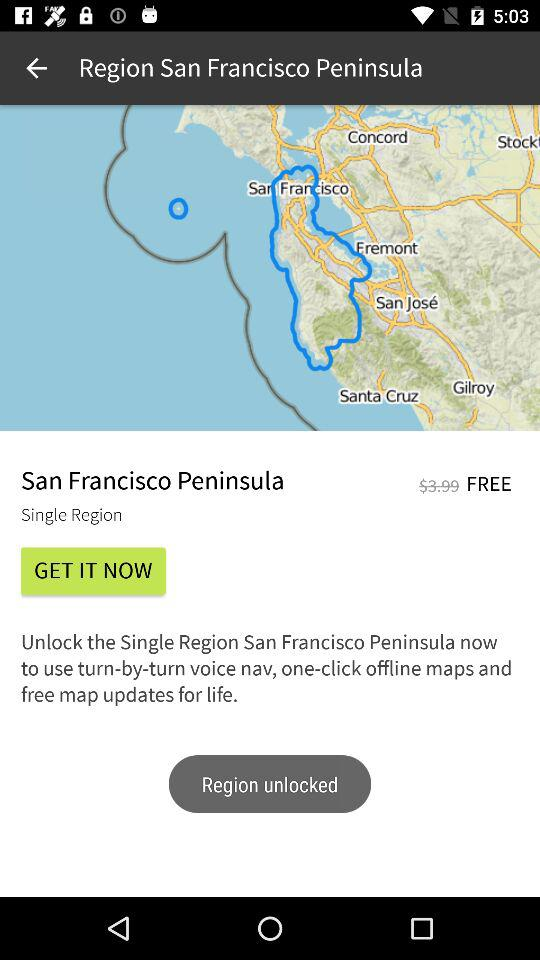How much more does it cost to unlock the San Francisco Peninsula region than the free region?
Answer the question using a single word or phrase. $3.99 